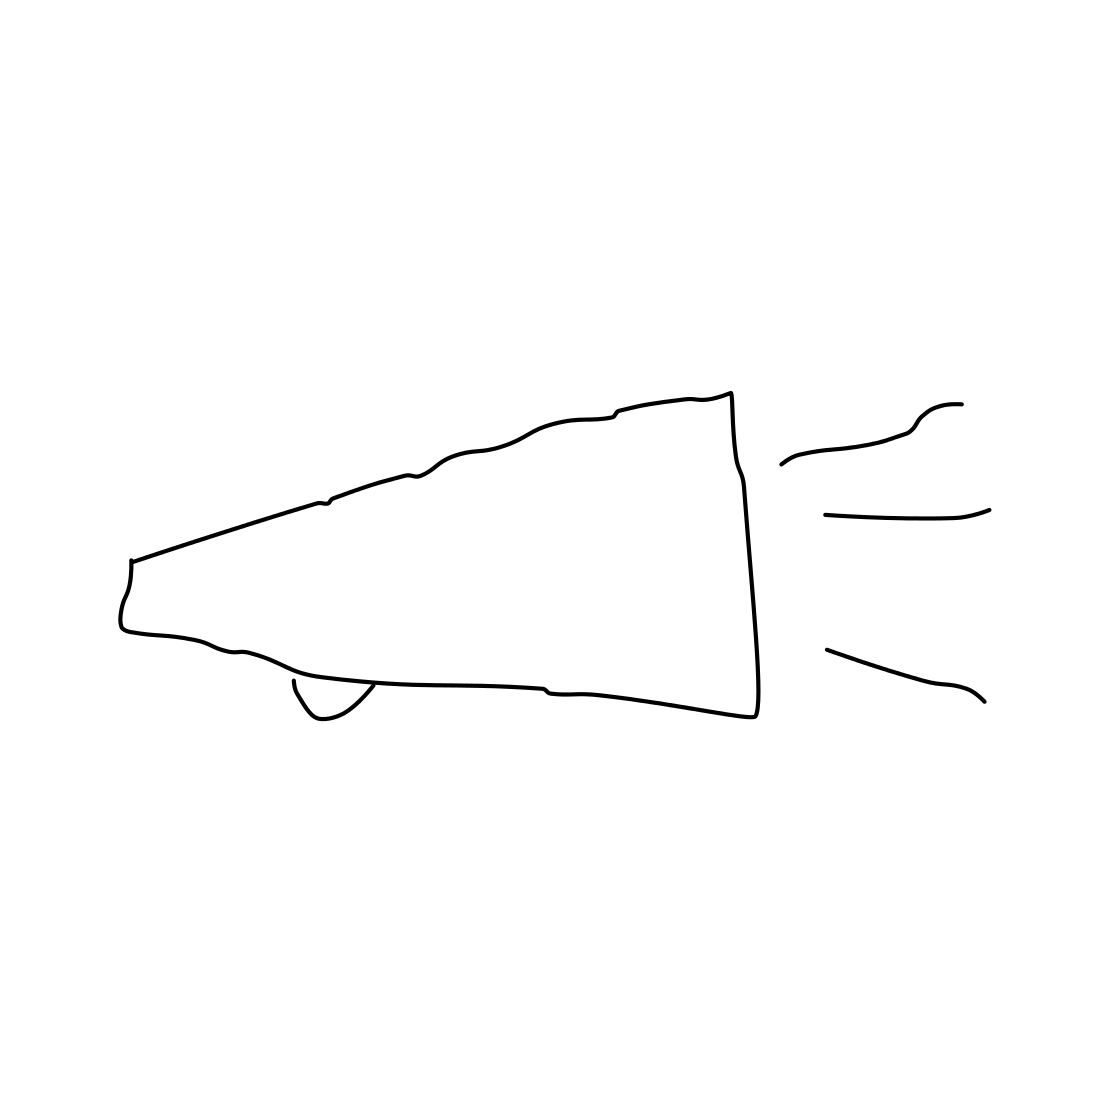Is there a sketchy megaphone in the picture? Yes 